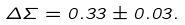Convert formula to latex. <formula><loc_0><loc_0><loc_500><loc_500>\Delta \Sigma = 0 . 3 3 \pm 0 . 0 3 .</formula> 